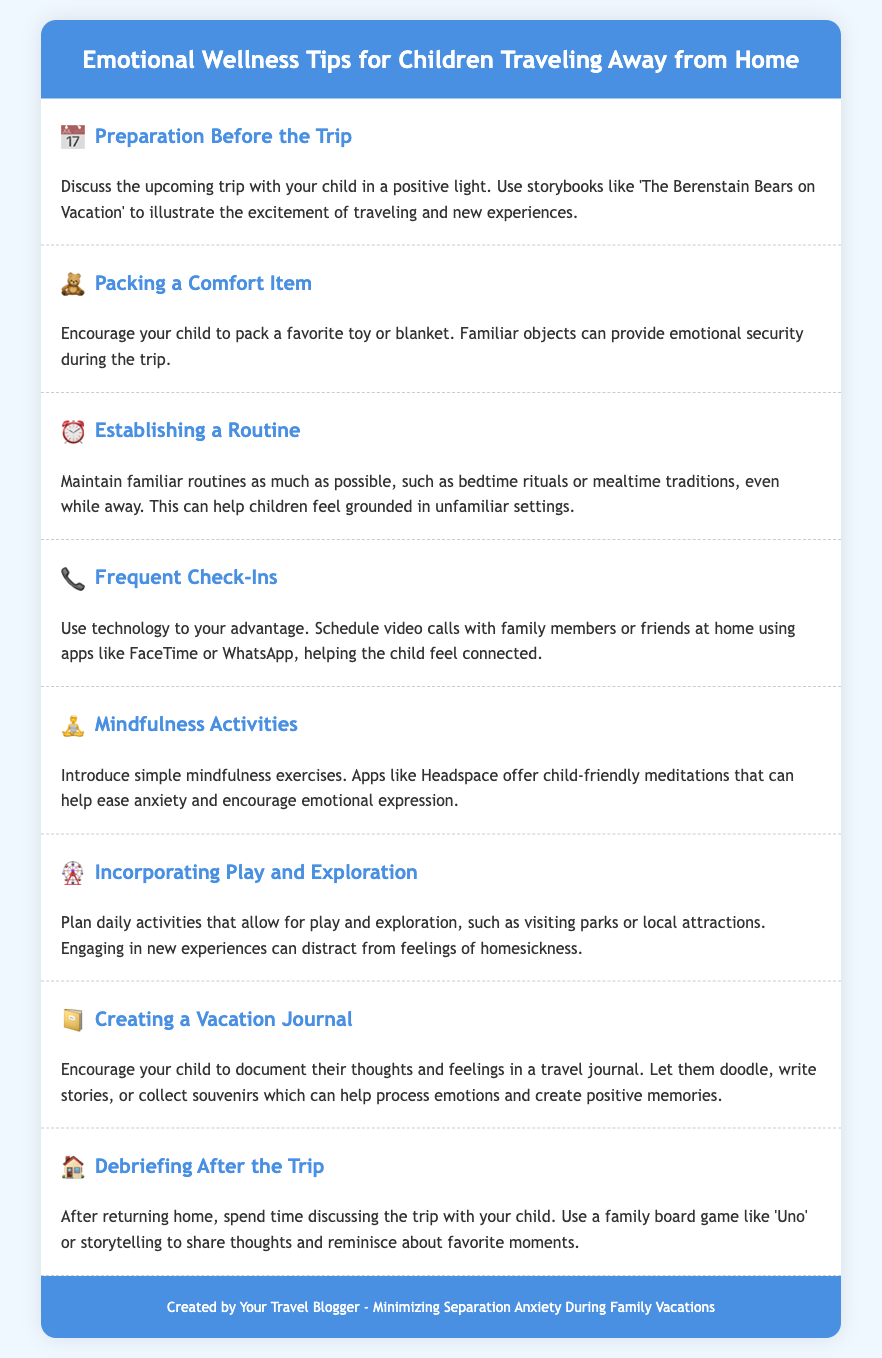what is the title of the document? The title appears at the top of the document in the header section, which is "Emotional Wellness Tips for Children Traveling Away from Home."
Answer: Emotional Wellness Tips for Children Traveling Away from Home how many agenda items are listed? The number of agenda items can be counted within the document; there are eight distinct sections each marked as an agenda item.
Answer: 8 what is a suggested item to pack for emotional security? The document suggests packing a favorite toy or blanket for emotional security during travel.
Answer: favorite toy or blanket which app is mentioned for mindfulness activities? The document recommends using an app for introducing mindfulness exercises; specifically, it mentions Headspace.
Answer: Headspace what is one activity suggested for debriefing after the trip? Among the suggested activities for debriefing, the document mentions using a family board game like 'Uno' for discussion.
Answer: 'Uno' how should video calls be used according to the document? The document states that video calls should be scheduled with family members or friends to help the child feel connected.
Answer: scheduled with family members or friends what is the purpose of a vacation journal? The document mentions that a vacation journal can help children process emotions and create positive memories.
Answer: process emotions and create positive memories what is suggested for maintaining routines? The document advises maintaining familiar routines such as bedtime rituals or mealtime traditions even while away.
Answer: bedtime rituals or mealtime traditions 